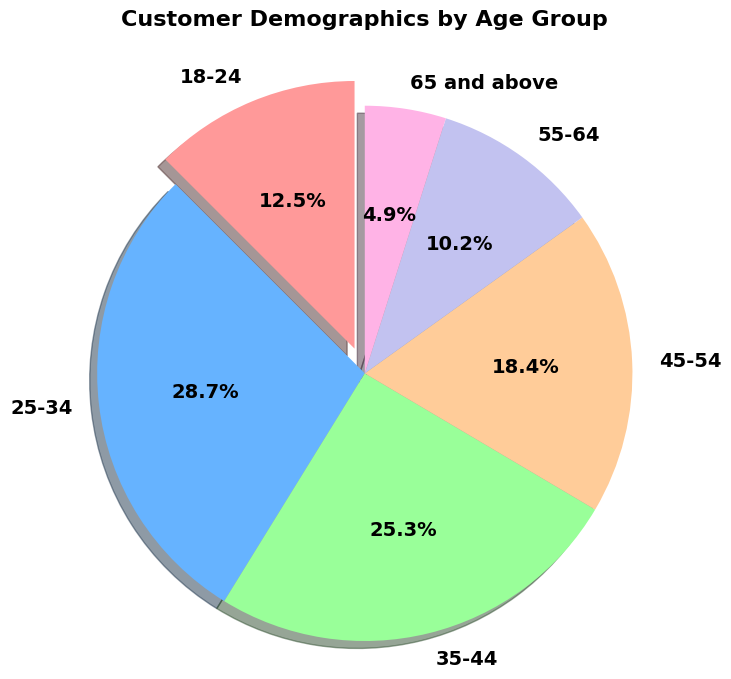How many age groups are represented in the chart? The pie chart labels represent different age groups. Count the unique labels to find the number of age groups.
Answer: 6 Which age group has the highest percentage of customers? Look at the pie chart slices and their corresponding percentages. Identify the age group with the largest percentage.
Answer: 25-34 What is the total percentage of customers aged 35-54? Sum the percentages of the 35-44 and 45-54 age groups: 25.3% + 18.4%.
Answer: 43.7% Is the percentage of customers aged 55-64 greater than those aged 65 and above? Compare the percentages for the age groups 55-64 (10.2%) and 65 and above (4.9%).
Answer: Yes Which age group is represented by the color red? Identify the color used for each age group in the pie chart and find the one that is red.
Answer: 18-24 What percentage of customers are under 35 years old? Sum the percentages of the 18-24 and 25-34 age groups: 12.5% + 28.7%.
Answer: 41.2% What is the difference in percentage between the 25-34 and 55-64 age groups? Subtract the percentage of the 55-64 age group (10.2%) from the 25-34 age group (28.7%).
Answer: 18.5% Which age group has the smallest slice in the pie chart? Observe the pie chart and identify the age group with the smallest slice.
Answer: 65 and above If the percentages of the 25-34 and 18-24 groups are combined, does it exceed 40%? Sum the percentages of the 25-34 and 18-24 age groups: 28.7% + 12.5%, and check if the total exceeds 40%.
Answer: Yes What is the combined percentage of customers aged 45 and above? Sum the percentages of the 45-54, 55-64, and 65 and above age groups: 18.4% + 10.2% + 4.9%.
Answer: 33.5% 